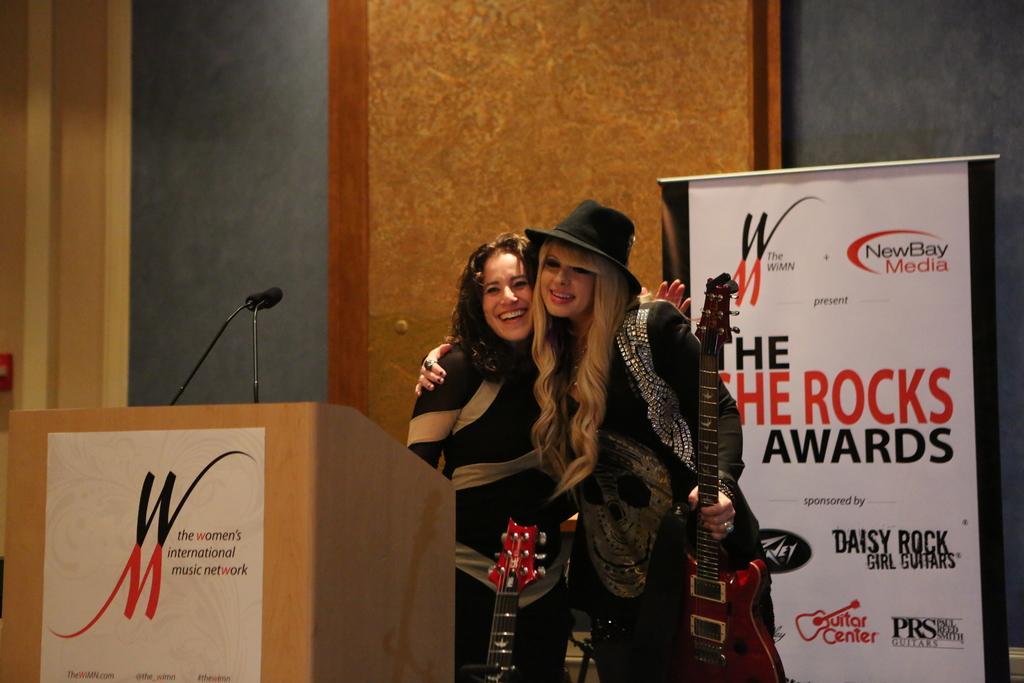Could you give a brief overview of what you see in this image? As we can see in the image there is a wall, two people standing on stage, a poster and a mike. 